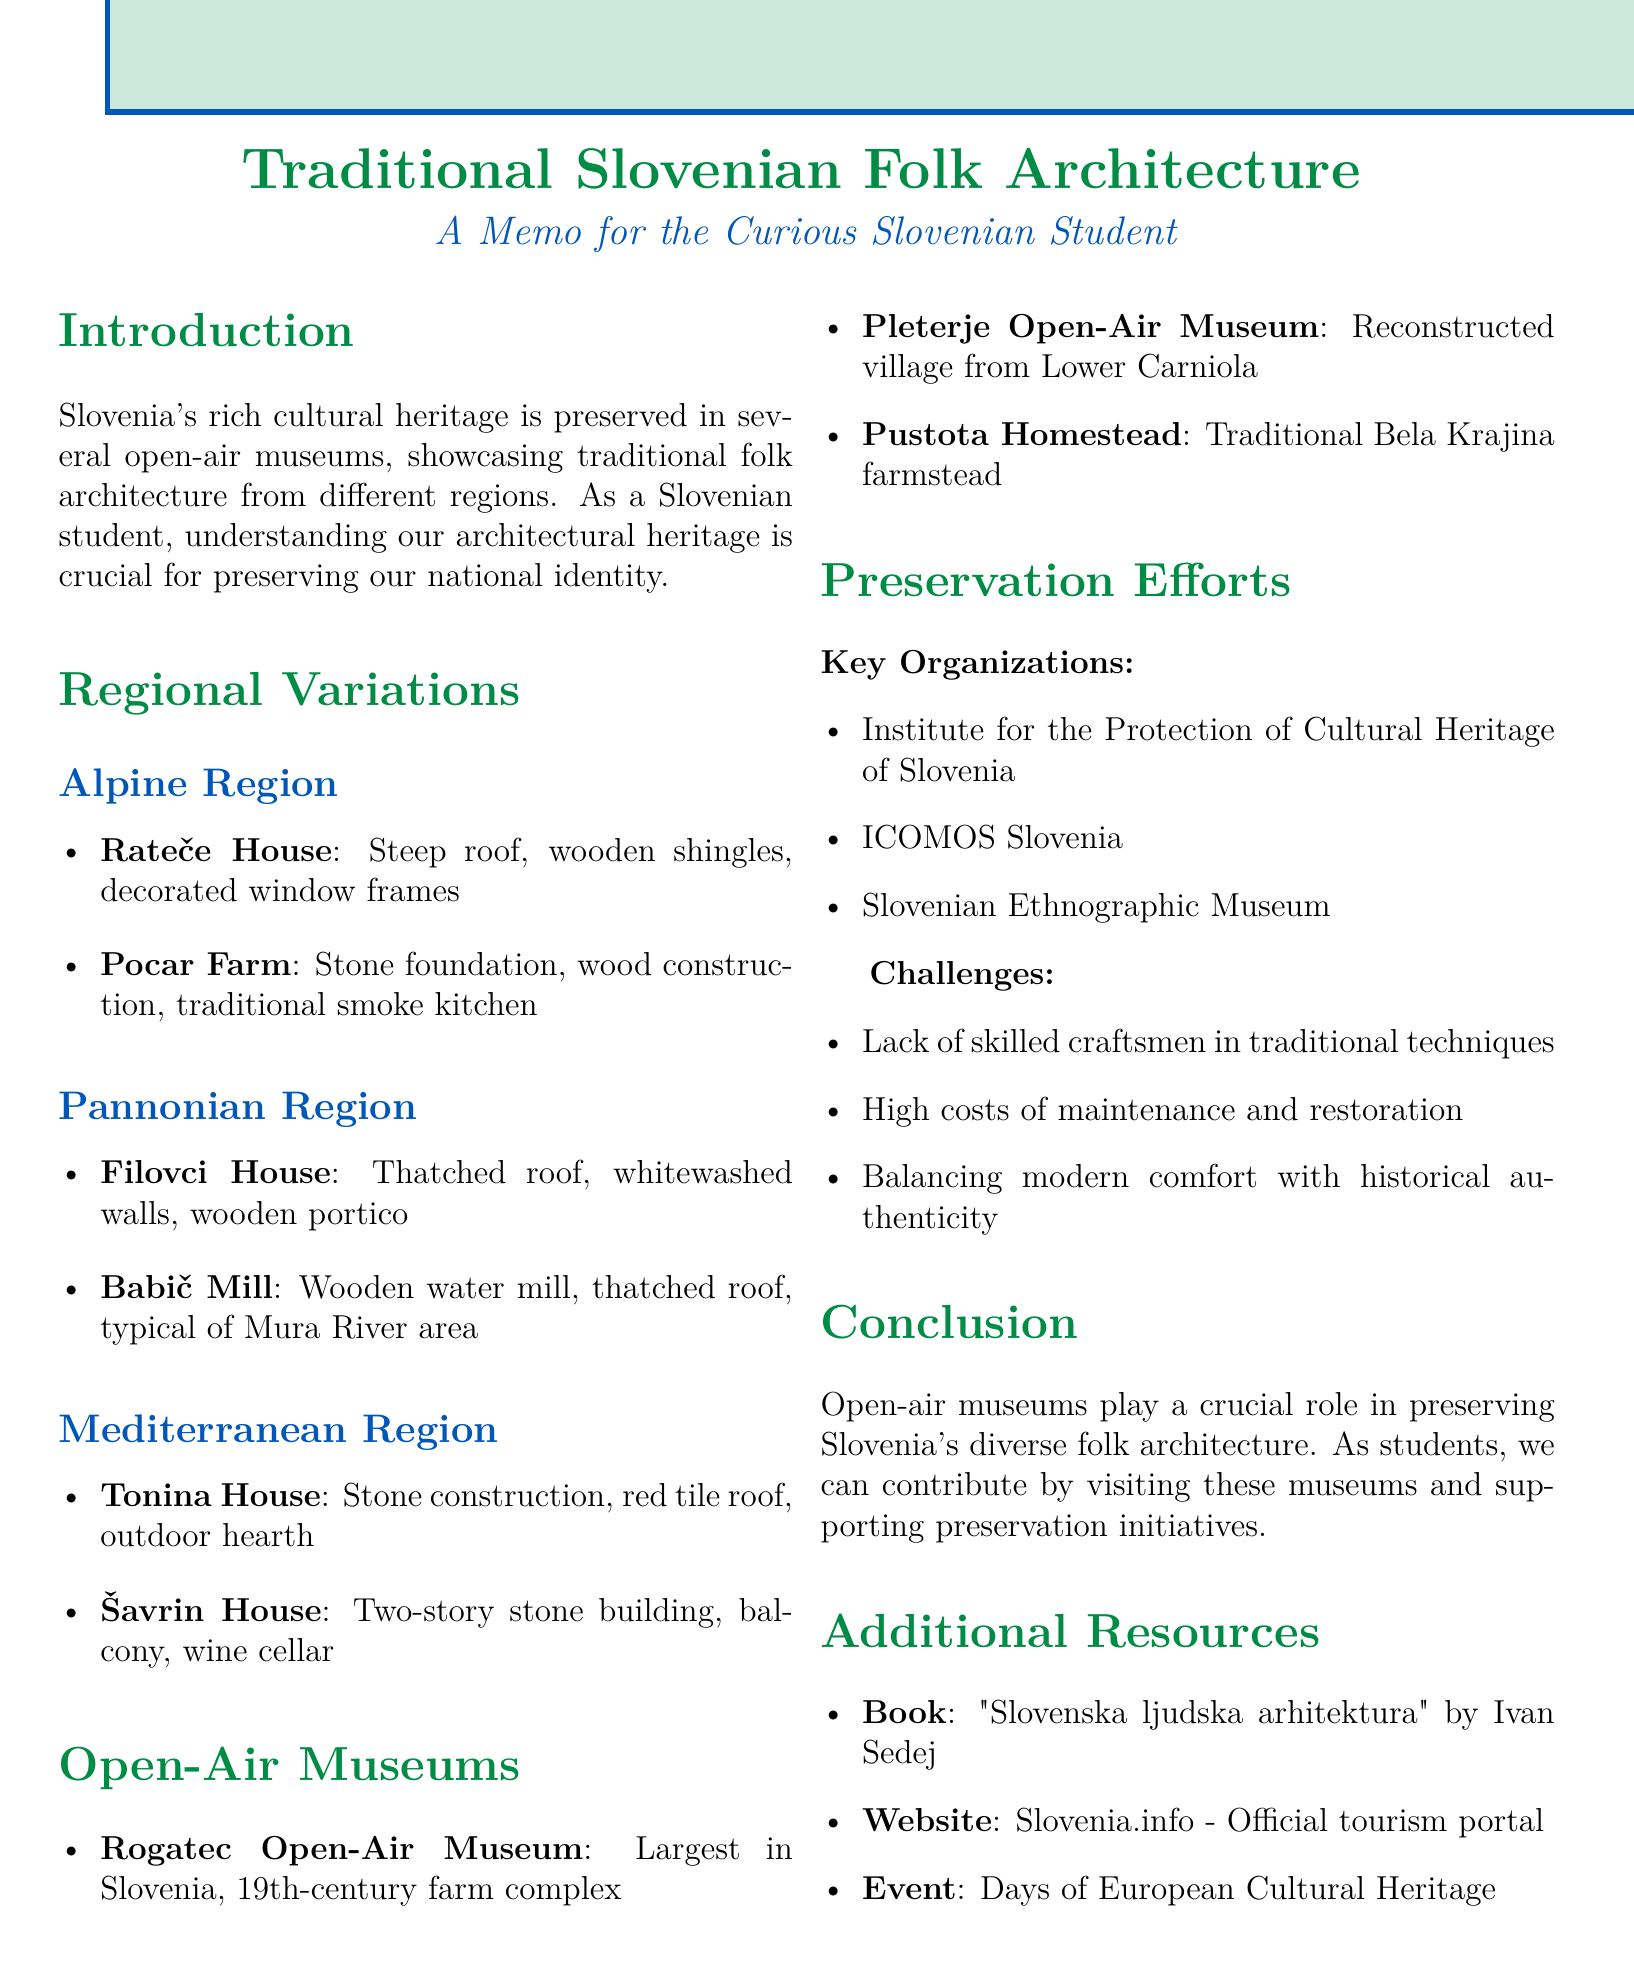What is the title of the document? The title is provided at the beginning of the document and summarizes its main topic.
Answer: Traditional Slovenian Folk Architecture in Open-Air Museums How many regions are highlighted in the document? The main sections cover three different regions related to traditional Slovenian folk architecture.
Answer: Three What is a key challenge in preservation efforts mentioned in the document? The document lists challenges under preservation efforts, focusing on the difficulties encountered in maintaining traditional architecture.
Answer: Lack of skilled craftsmen in traditional building techniques Where is the Rogatec Open-Air Museum located? The document provides specific locations for each museum mentioned, including Rogatec.
Answer: Rogatec Which organization oversees the preservation of traditional architecture in Slovenia? The document names key organizations and their roles in preserving cultural heritage.
Answer: Institute for the Protection of Cultural Heritage of Slovenia What is a feature of the Rateče House? Each example of folk architecture includes specific features that distinguish them.
Answer: Steep roof Which event showcases Slovenia's architectural heritage? The document includes additional resources where events related to cultural heritage are listed.
Answer: Days of European Cultural Heritage What type of architecture is primarily discussed in the document? The document is centered around a specific type of cultural structure that represents traditional aesthetics.
Answer: Folk architecture What is a feature of the Tonina House? The document details features of various homes in the Mediterranean region, including this specific example.
Answer: Stone construction 